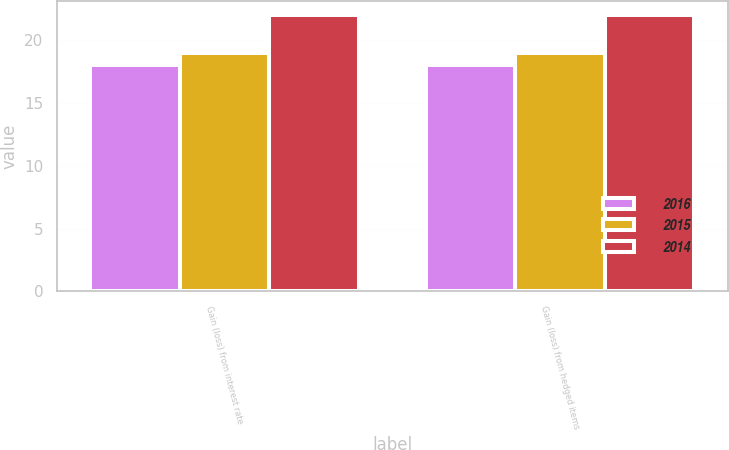Convert chart to OTSL. <chart><loc_0><loc_0><loc_500><loc_500><stacked_bar_chart><ecel><fcel>Gain (loss) from interest rate<fcel>Gain (loss) from hedged items<nl><fcel>2016<fcel>18<fcel>18<nl><fcel>2015<fcel>19<fcel>19<nl><fcel>2014<fcel>22<fcel>22<nl></chart> 